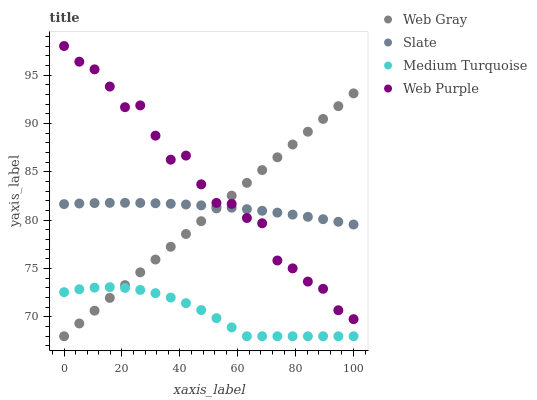Does Medium Turquoise have the minimum area under the curve?
Answer yes or no. Yes. Does Web Purple have the maximum area under the curve?
Answer yes or no. Yes. Does Web Gray have the minimum area under the curve?
Answer yes or no. No. Does Web Gray have the maximum area under the curve?
Answer yes or no. No. Is Web Gray the smoothest?
Answer yes or no. Yes. Is Web Purple the roughest?
Answer yes or no. Yes. Is Web Purple the smoothest?
Answer yes or no. No. Is Web Gray the roughest?
Answer yes or no. No. Does Web Gray have the lowest value?
Answer yes or no. Yes. Does Web Purple have the lowest value?
Answer yes or no. No. Does Web Purple have the highest value?
Answer yes or no. Yes. Does Web Gray have the highest value?
Answer yes or no. No. Is Medium Turquoise less than Slate?
Answer yes or no. Yes. Is Web Purple greater than Medium Turquoise?
Answer yes or no. Yes. Does Slate intersect Web Purple?
Answer yes or no. Yes. Is Slate less than Web Purple?
Answer yes or no. No. Is Slate greater than Web Purple?
Answer yes or no. No. Does Medium Turquoise intersect Slate?
Answer yes or no. No. 